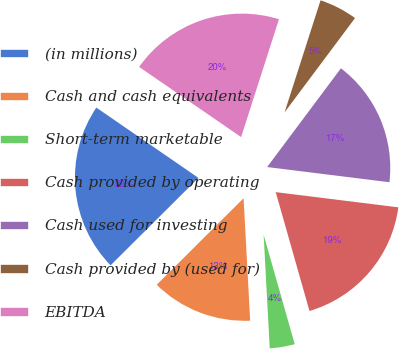Convert chart to OTSL. <chart><loc_0><loc_0><loc_500><loc_500><pie_chart><fcel>(in millions)<fcel>Cash and cash equivalents<fcel>Short-term marketable<fcel>Cash provided by operating<fcel>Cash used for investing<fcel>Cash provided by (used for)<fcel>EBITDA<nl><fcel>22.06%<fcel>13.39%<fcel>3.55%<fcel>18.63%<fcel>16.75%<fcel>5.27%<fcel>20.35%<nl></chart> 